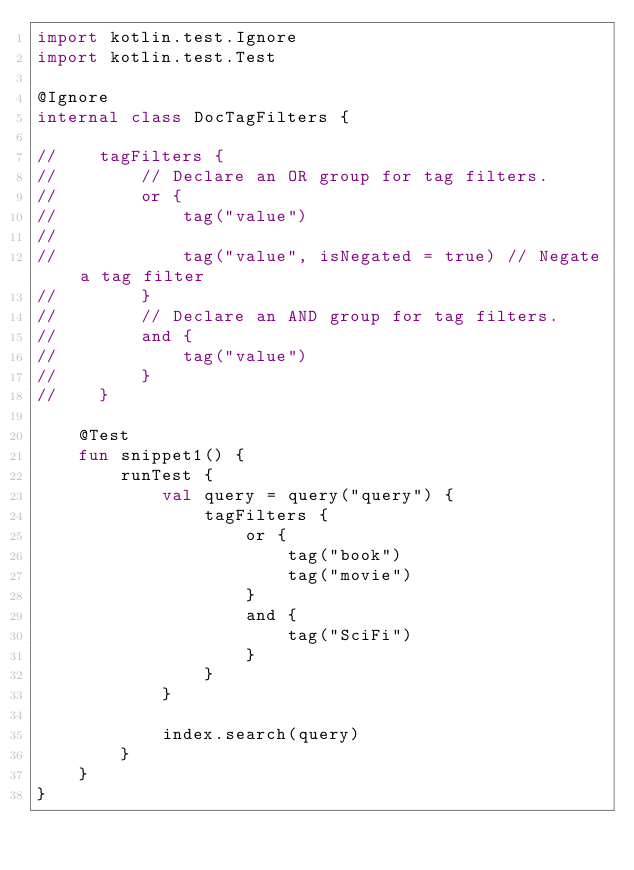Convert code to text. <code><loc_0><loc_0><loc_500><loc_500><_Kotlin_>import kotlin.test.Ignore
import kotlin.test.Test

@Ignore
internal class DocTagFilters {

//    tagFilters {
//        // Declare an OR group for tag filters.
//        or {
//            tag("value")
//
//            tag("value", isNegated = true) // Negate a tag filter
//        }
//        // Declare an AND group for tag filters.
//        and {
//            tag("value")
//        }
//    }

    @Test
    fun snippet1() {
        runTest {
            val query = query("query") {
                tagFilters {
                    or {
                        tag("book")
                        tag("movie")
                    }
                    and {
                        tag("SciFi")
                    }
                }
            }

            index.search(query)
        }
    }
}
</code> 